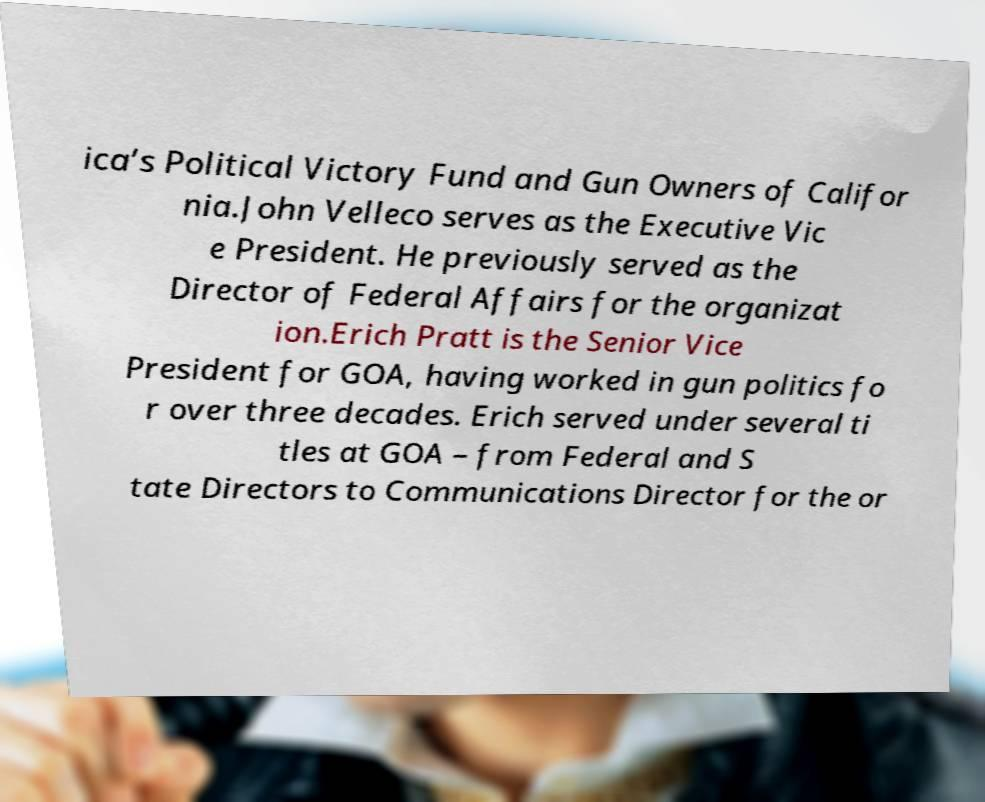Can you read and provide the text displayed in the image?This photo seems to have some interesting text. Can you extract and type it out for me? ica’s Political Victory Fund and Gun Owners of Califor nia.John Velleco serves as the Executive Vic e President. He previously served as the Director of Federal Affairs for the organizat ion.Erich Pratt is the Senior Vice President for GOA, having worked in gun politics fo r over three decades. Erich served under several ti tles at GOA – from Federal and S tate Directors to Communications Director for the or 